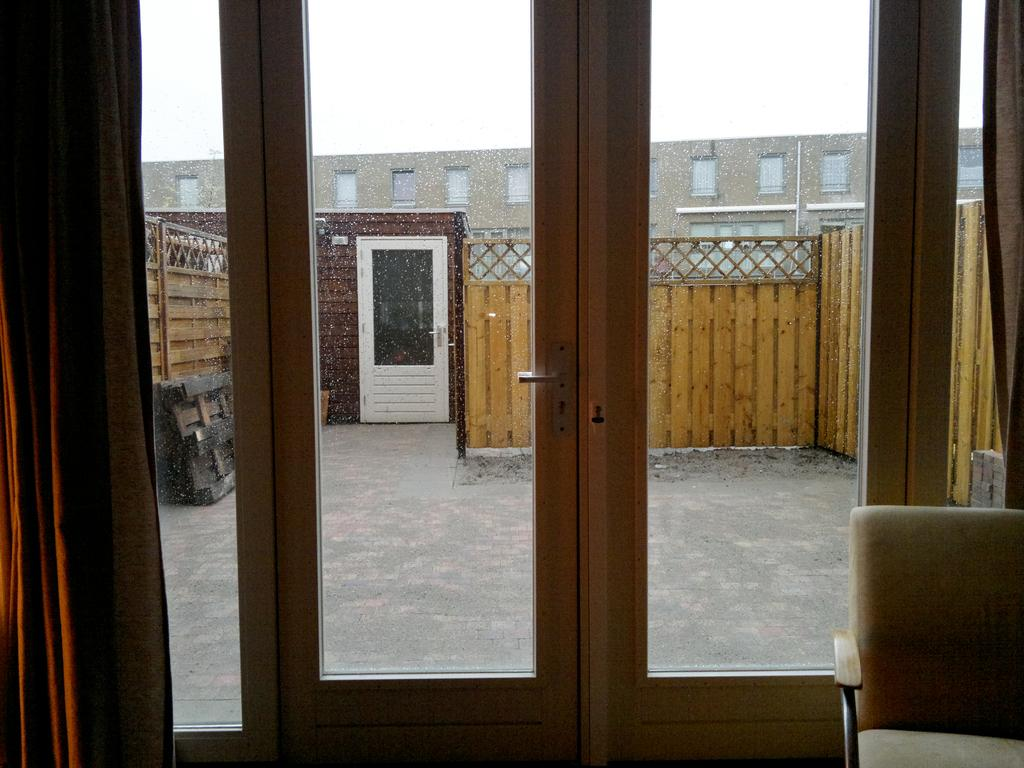What type of structures can be seen in the image? There are doors, a chair, a wooden fence, and a building visible in the image. Where is the building located in the image? The building is in the image. What can be seen in the background of the image? The sky is visible in the background of the image. How many bats are hanging from the wooden fence in the image? There are no bats present in the image; it features a wooden fence, doors, a chair, and a building. What type of spiders can be seen spinning webs on the doors in the image? There are no spiders present in the image; it only features doors, a chair, a wooden fence, and a building. 